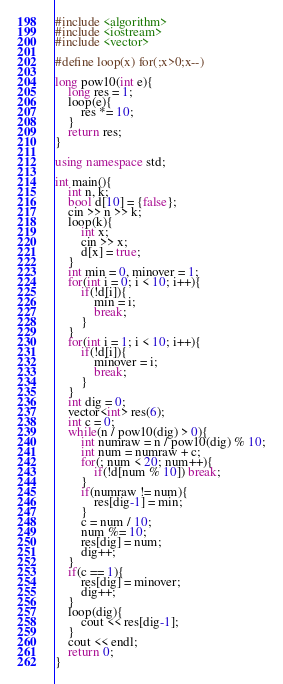Convert code to text. <code><loc_0><loc_0><loc_500><loc_500><_C++_>#include <algorithm>
#include <iostream>
#include <vector>

#define loop(x) for(;x>0;x--)

long pow10(int e){
    long res = 1;
    loop(e){
        res *= 10;
    }
    return res;
}

using namespace std;

int main(){
    int n, k;
    bool d[10] = {false};
    cin >> n >> k;
    loop(k){
        int x;
        cin >> x;
        d[x] = true;
    }
    int min = 0, minover = 1;
    for(int i = 0; i < 10; i++){
        if(!d[i]){
            min = i;
            break;
        }
    }
    for(int i = 1; i < 10; i++){
        if(!d[i]){
            minover = i;
            break;
        }
    }
    int dig = 0;
    vector<int> res(6);
    int c = 0;
    while(n / pow10(dig) > 0){
        int numraw = n / pow10(dig) % 10;
        int num = numraw + c;
        for(; num < 20; num++){
            if(!d[num % 10]) break;
        }
        if(numraw != num){
            res[dig-1] = min;
        }
        c = num / 10;
        num %= 10;
        res[dig] = num;
        dig++;
    }
    if(c == 1){
        res[dig] = minover;
        dig++;
    }
    loop(dig){
        cout << res[dig-1];
    }
    cout << endl;
    return 0;
}</code> 